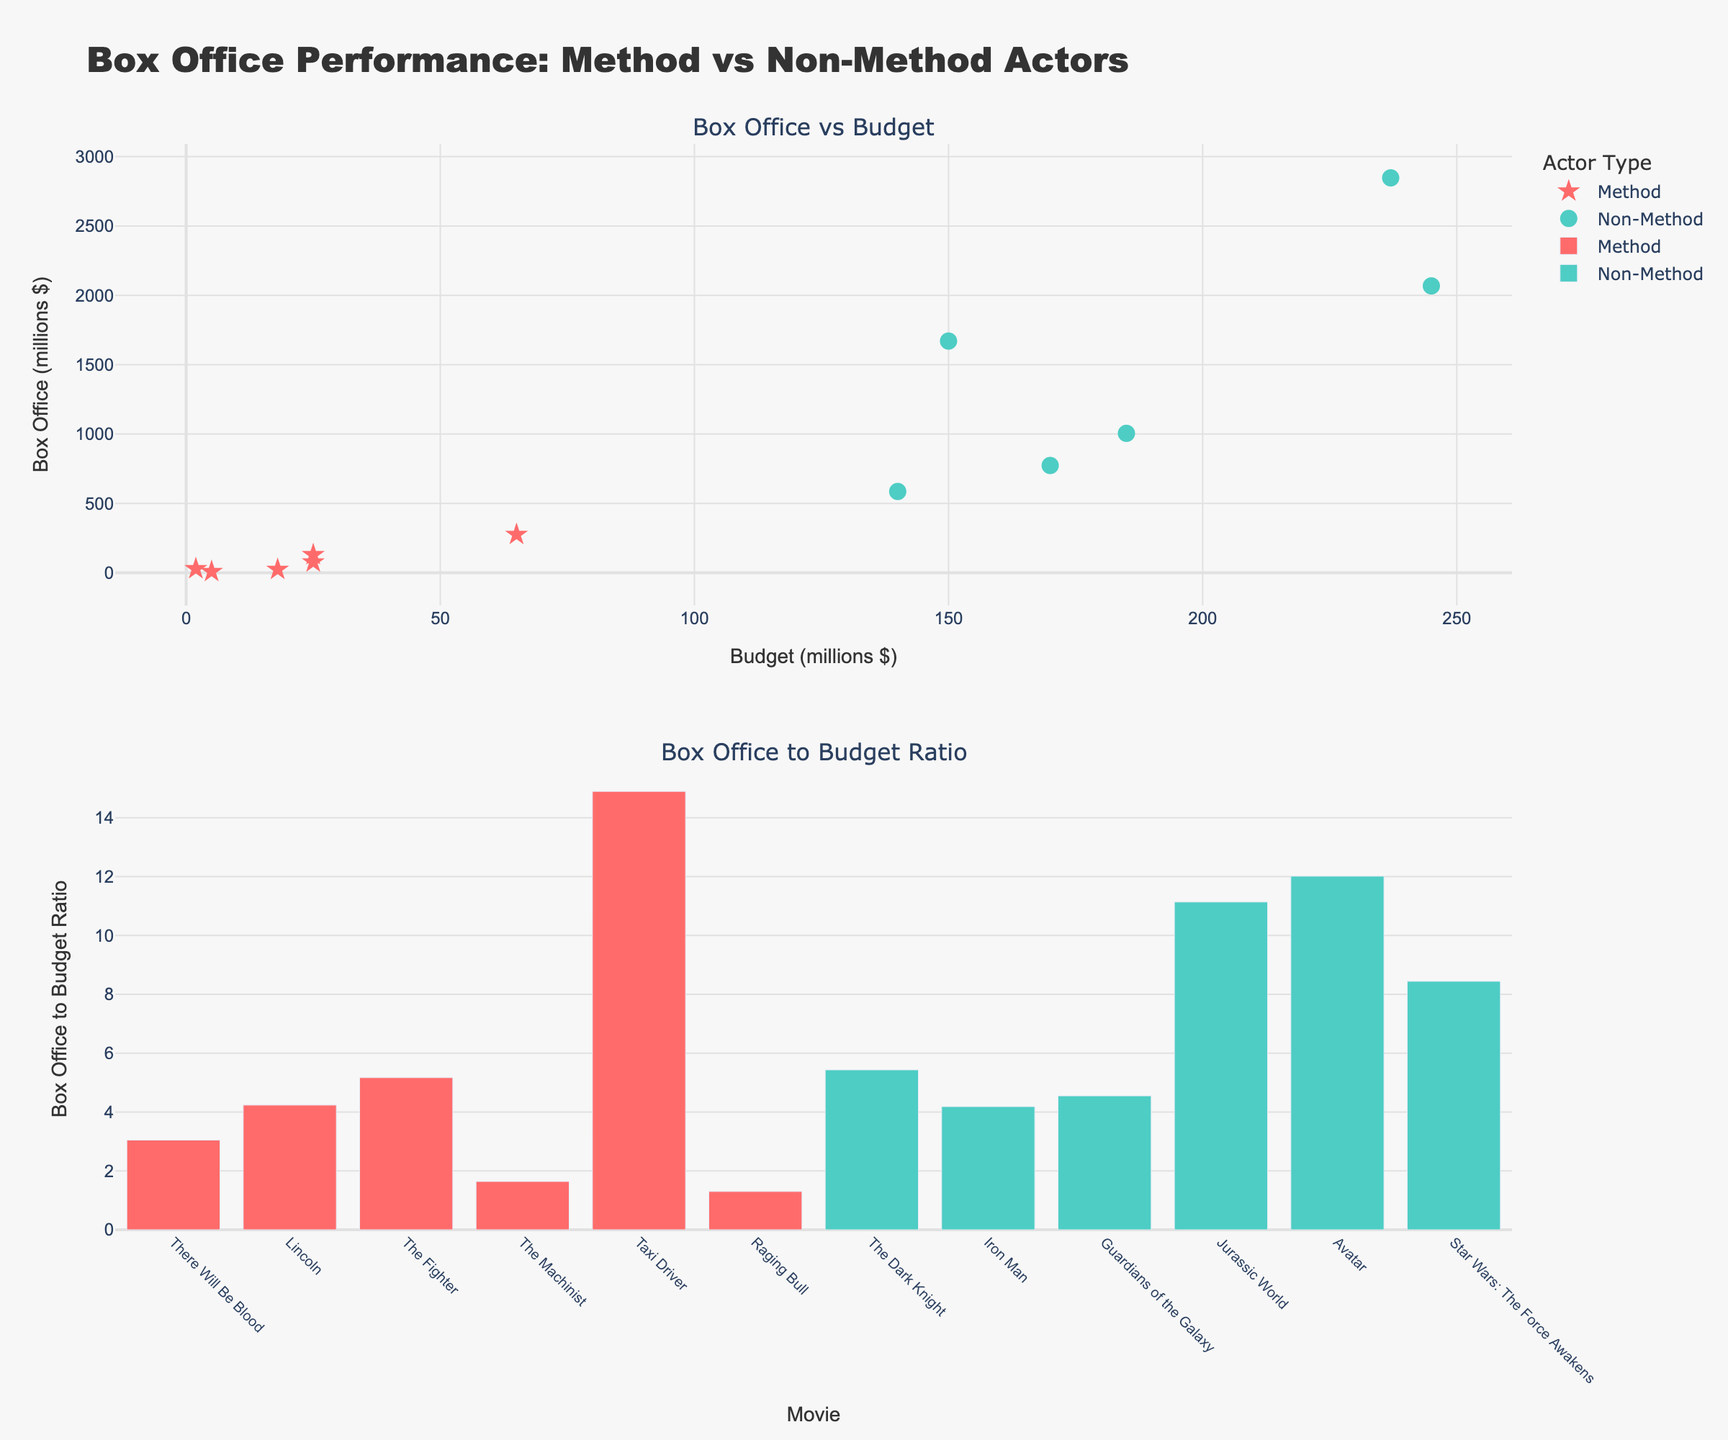What is the title of the figure? The title is located at the top of the figure and reads "Box Office Performance: Method vs Non-Method Actors"
Answer: Box Office Performance: Method vs Non-Method Actors How many method actor movies are plotted in the top subplot? Count the number of data points (stars) representing method actor movies in the top subplot
Answer: 5 Which method actor movie has the highest Box Office to Budget Ratio in the bottom subplot? Compare the heights of the red bars representing method actor movies in the bottom subplot to find the highest one. "The Fighter" has the tallest red bar
Answer: The Fighter What is the budget of "Avatar"? Look for the position of "Avatar" in the top subplot, represented by a green circle, and check its x-axis value
Answer: 237 million dollars Which movie has the highest box office performance among non-method actor movies, and what is its value? Identify the highest green circle in the top subplot and read its y-axis value. "Avatar" is the highest with a y-axis value of 2847.2 million dollars
Answer: Avatar, 2847.2 million dollars Calculate the average Box Office performance for the method actor movies shown in the plot Sum the Box Office values for method actor movies (76.2 + 275.3 + 129.2 + 8.2 + 28.3 + 23.4) and divide by the number of movies (6)
Answer: 90.1 million dollars Compare the budget and box office of "There Will Be Blood" to "The Dark Knight". Which one has a higher box office to budget ratio? Calculate the ratio for each ("There Will Be Blood": 76.2/25 = 3.048, "The Dark Knight": 1005.0/185 = 5.432) and compare the two. The Dark Knight has a higher ratio
Answer: The Dark Knight Which movie has the lowest box office performance among method actor movies, and what is its value? Identify the lowest red star in the top subplot and read its y-axis value. "The Machinist" is the lowest with a y-axis value of 8.2 million dollars
Answer: The Machinist, 8.2 million dollars How many non-method actor movies have a budget of over 200 million dollars? Count the number of green circles in the top subplot whose x-axis values are greater than 200
Answer: 2 